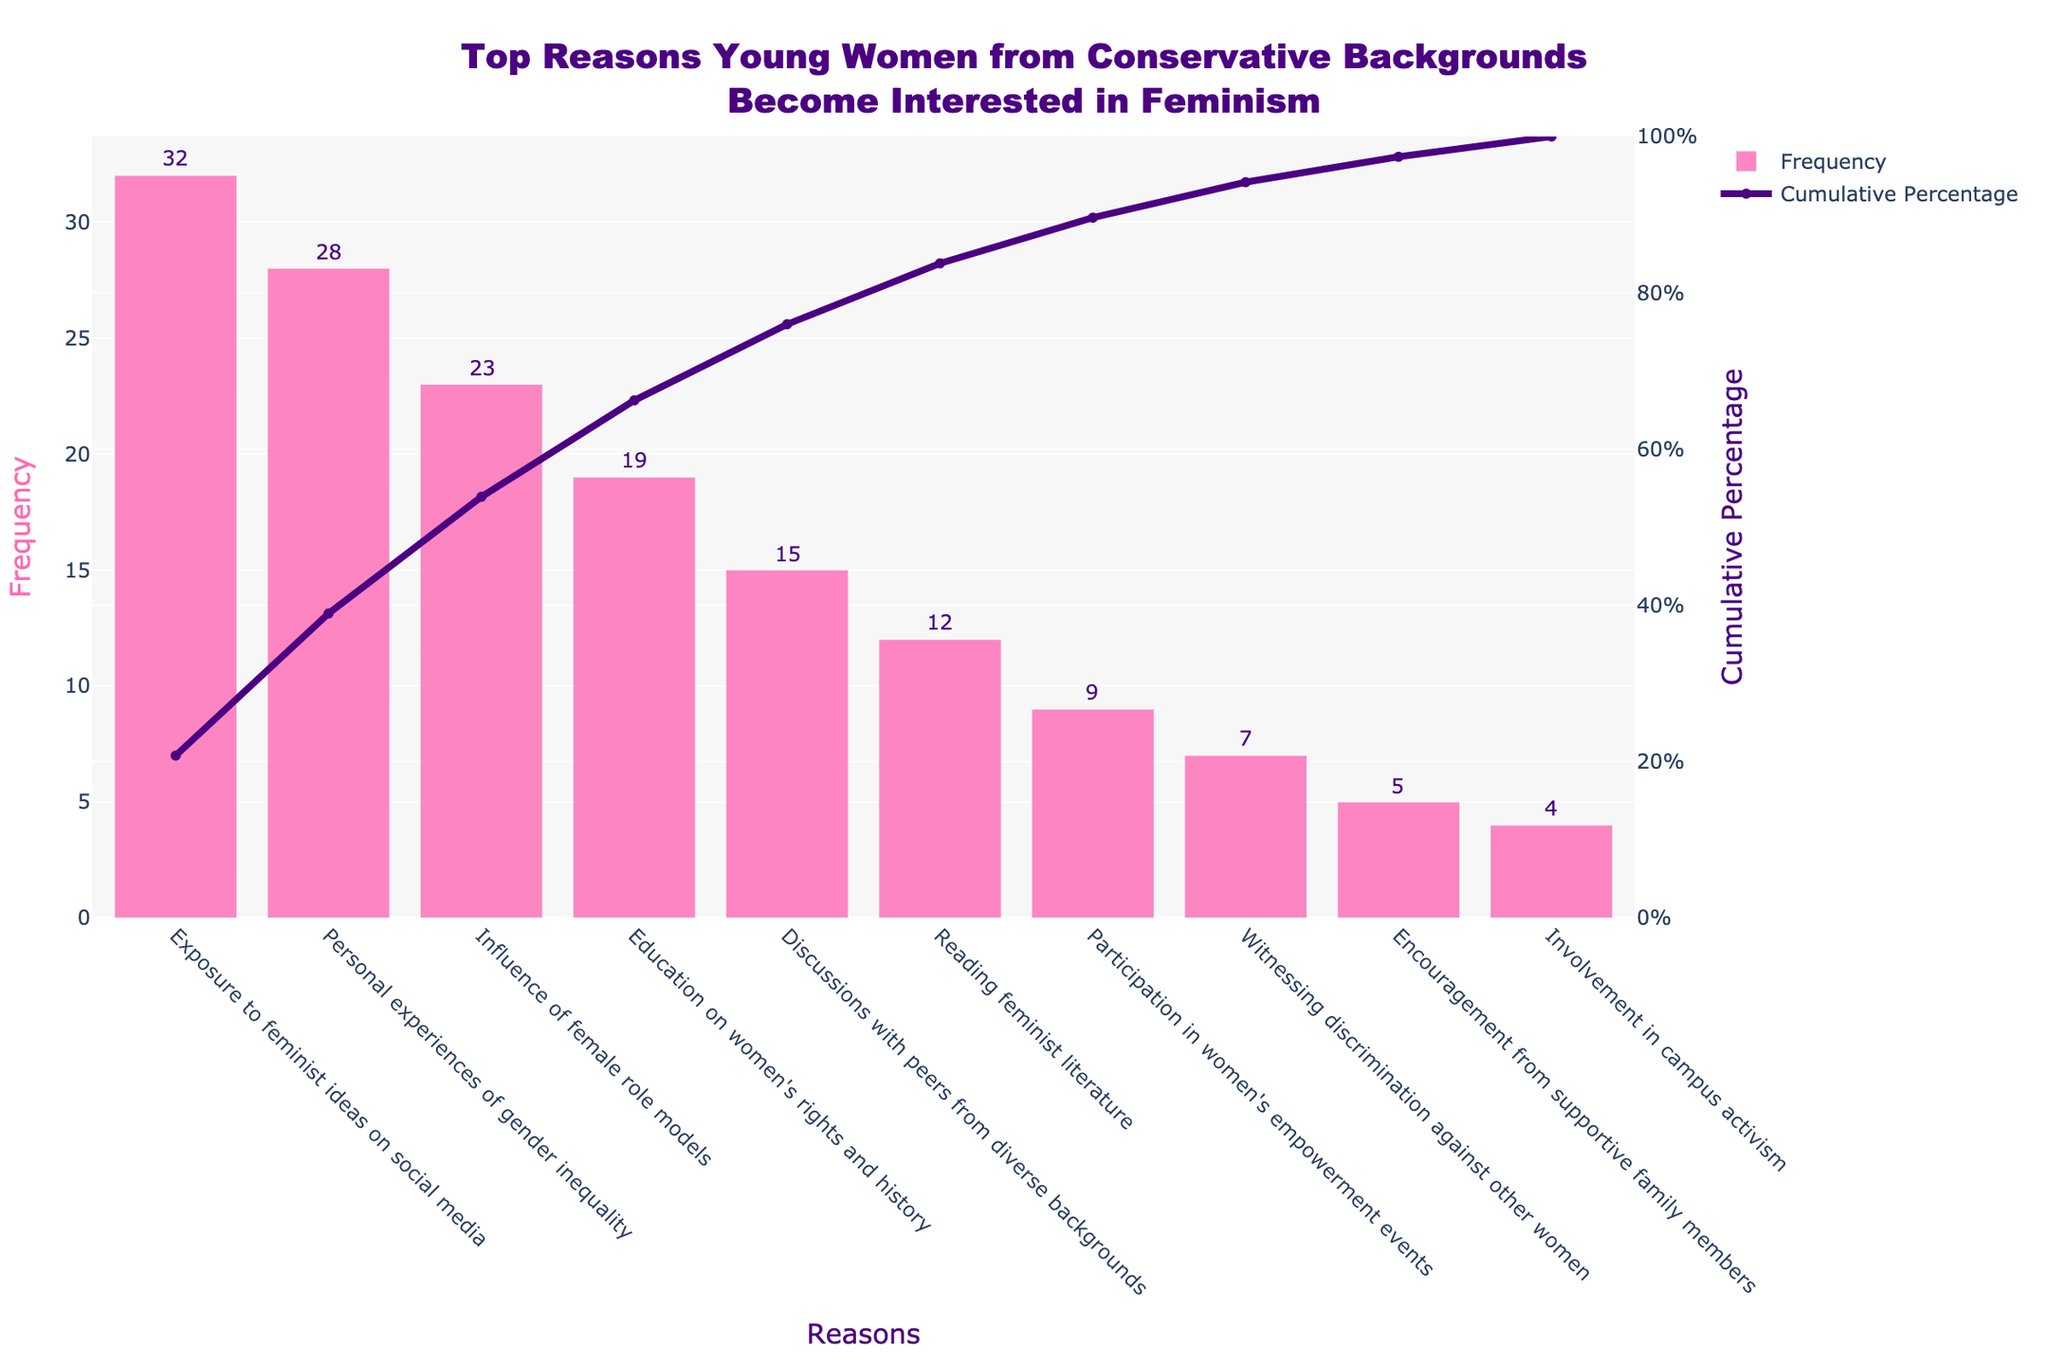What's the title of the figure? The title of the figure is found at the top and is often used to provide context to what the figure represents. Reading it directly reveals the content at a glance.
Answer: Top Reasons Young Women from Conservative Backgrounds Become Interested in Feminism What is the most frequent reason young women from conservative backgrounds become interested in feminism? The highest bar in the chart represents the most frequent reason. By observing which bar is the tallest, we can identify it.
Answer: Exposure to feminist ideas on social media How many reasons have a frequency of 10 or less? To find this, we count the bars that represent reasons with frequencies of 10 or less. These are 'Reading feminist literature', 'Participation in women's empowerment events', 'Witnessing discrimination against other women', 'Encouragement from supportive family members', and 'Involvement in campus activism'.
Answer: 5 What is the cumulative percentage for 'Influence of female role models'? Locate the corresponding point on the graph's line for 'Influence of female role models' and read the cumulative percentage value at that point.
Answer: 68% What is the difference in frequency between 'Exposure to feminist ideas on social media' and 'Personal experiences of gender inequality'? Subtract the frequency of 'Personal experiences of gender inequality' from 'Exposure to feminist ideas on social media'. 32 (social media) - 28 (personal experiences) = 4.
Answer: 4 Which two reasons have cumulative percentages that sum to closest but less than 50%? Add the cumulative percentages from the beginning until the total is closest to but does not exceed 50%. 'Exposure to feminist ideas on social media' (32%) and 'Personal experiences of gender inequality' (28%) sum to 60%, which exceeds 50%. Checking lower sums: 'Exposure to feminist ideas on social media' (32%) and 'Influence of female role models' (23%) sum to 55% (also too high). 'Exposure to feminist ideas on social media' alone at 32% is still the best individual percentage under 50%. For the sum still looking for best pairs below 50%. 'Personal experiences of gender inequality'(28%) + 'Influence of female role models' (23%) is = 51% again too high. So 'Personal experiences of gender inequality' at 28% cumulative and preceding cause is best
Answer: Exposure to feminist ideas on social media What frequency is associated with the cumulatively last 10% or less? This involves identifying the bars that make up the difference from 90% to 100% cumulative percentage. These bars are 'Encouragement from supportive family members' (5) and 'Involvement in campus activism' (4).
Answer: 5 and 4 respectively What's the total frequency of the three least common reasons combined? Sum the frequencies of the three reasons with the smallest frequencies. Involvement in campus activism (4), Encouragement from supportive family members (5), and Witnessing discrimination against other women (7). 4 + 5 + 7 = 16.
Answer: 16 